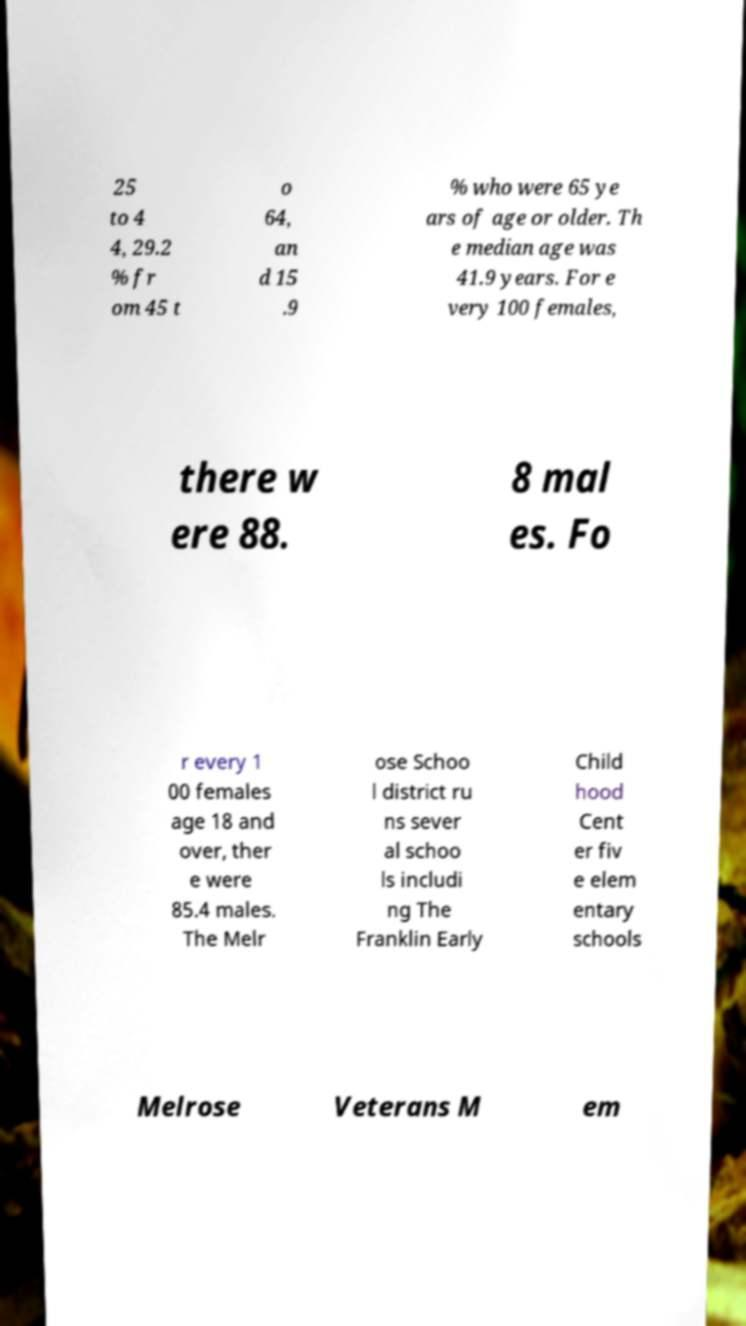Could you extract and type out the text from this image? 25 to 4 4, 29.2 % fr om 45 t o 64, an d 15 .9 % who were 65 ye ars of age or older. Th e median age was 41.9 years. For e very 100 females, there w ere 88. 8 mal es. Fo r every 1 00 females age 18 and over, ther e were 85.4 males. The Melr ose Schoo l district ru ns sever al schoo ls includi ng The Franklin Early Child hood Cent er fiv e elem entary schools Melrose Veterans M em 